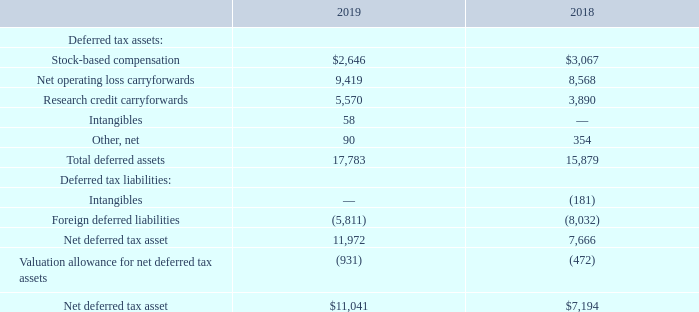Deferred Income Tax Assets and Liabilities
Significant components of the Company’s net deferred tax assets and liabilities as of September 30, 2019 and 2018 are as follows(amounts shown in thousands):
The net change in the total valuation allowance for the fiscal years ended September 30, 2019 and 2018 was an increase of $0.5 million and an increase of $0.4 million, respectively. In assessing the realizability of deferred tax assets, the Company considers whether it is more likely than not that some portion or all of the deferred tax assets will not be realized. The ultimate realization of deferred tax assets is dependent upon the generation of future taxable income during periods in which those temporary differences become deductible. The Company considers projected future taxable income and planning strategies in making this assessment. Based on the level of historical operating results and the projections for future taxable income, the Company has determined that it is more likely than not that the deferred tax assets may be realized for all deferred tax assets with the exception of the net foreign deferred tax assets at Mitek Systems B.V.
As of September 30, 2019, the Company has available net operating loss carryforwards of $29.5 million for federal income tax purposes, of which $2.1 million were generated in the fiscal year ended September 30, 2019 and can be carried forward indefinitely under the Tax Cuts and Jobs Act. The remaining federal net operating loss of $27.4 million, which were generated prior to the fiscal year ended September 30, 2019, will start to expire in2032 if not utilized. The net operating losses for state purposes are $29.4 million and will begin to expire in2028. As of September 30, 2019, the Company has available federal research and development credit carryforwards, net of reserves, of $2.8 million. The federal research and development credits will start to expire in2027. As of September 30, 2019, the Company has available California research and development credit carryforwards, net of reserves, of $2.4 million, which do not expire.
Sections 382 and 383 of the Internal Revenue Code of 1986, as amended (the “IRC”) limit the utilization of tax attribute carryforwards that arise prior to certain cumulative changes in a corporation’s ownership. The Company has completed an IRC Section 382/383 analysis through March 31, 2017 and any identified ownership changes had no impact to the utilization of tax attribute carryforwards. Any future ownership changes may have an impact on the utilization of the tax attribute carryforwards.
How does the Company assess the realizability of deferred tax assets? The company considers whether it is more likely than not that some portion or all of the deferred tax assets will not be realized. Which laws limit the utilization of tax attribute carryforwards that arise prior to certain cumulative changes in a corporation’s ownership? Sections 382 and 383 of the internal revenue code of 1986. What are the Company’s net deferred tax assets in 2018 and 2019, respectively?
Answer scale should be: thousand. $7,194, $11,041. What is the proportion of research credit carryforwards and intangible assets over total deferred assets in 2019? (5,570+58)/17,783 
Answer: 0.32. What is the percentage change in net deferred tax assets from 2018 to 2019?
Answer scale should be: percent. (11,041-7,194)/7,194 
Answer: 53.48. What is the average of total deferred assets from 2018 to 2019?
Answer scale should be: thousand. (17,783+15,879)/2 
Answer: 16831. 